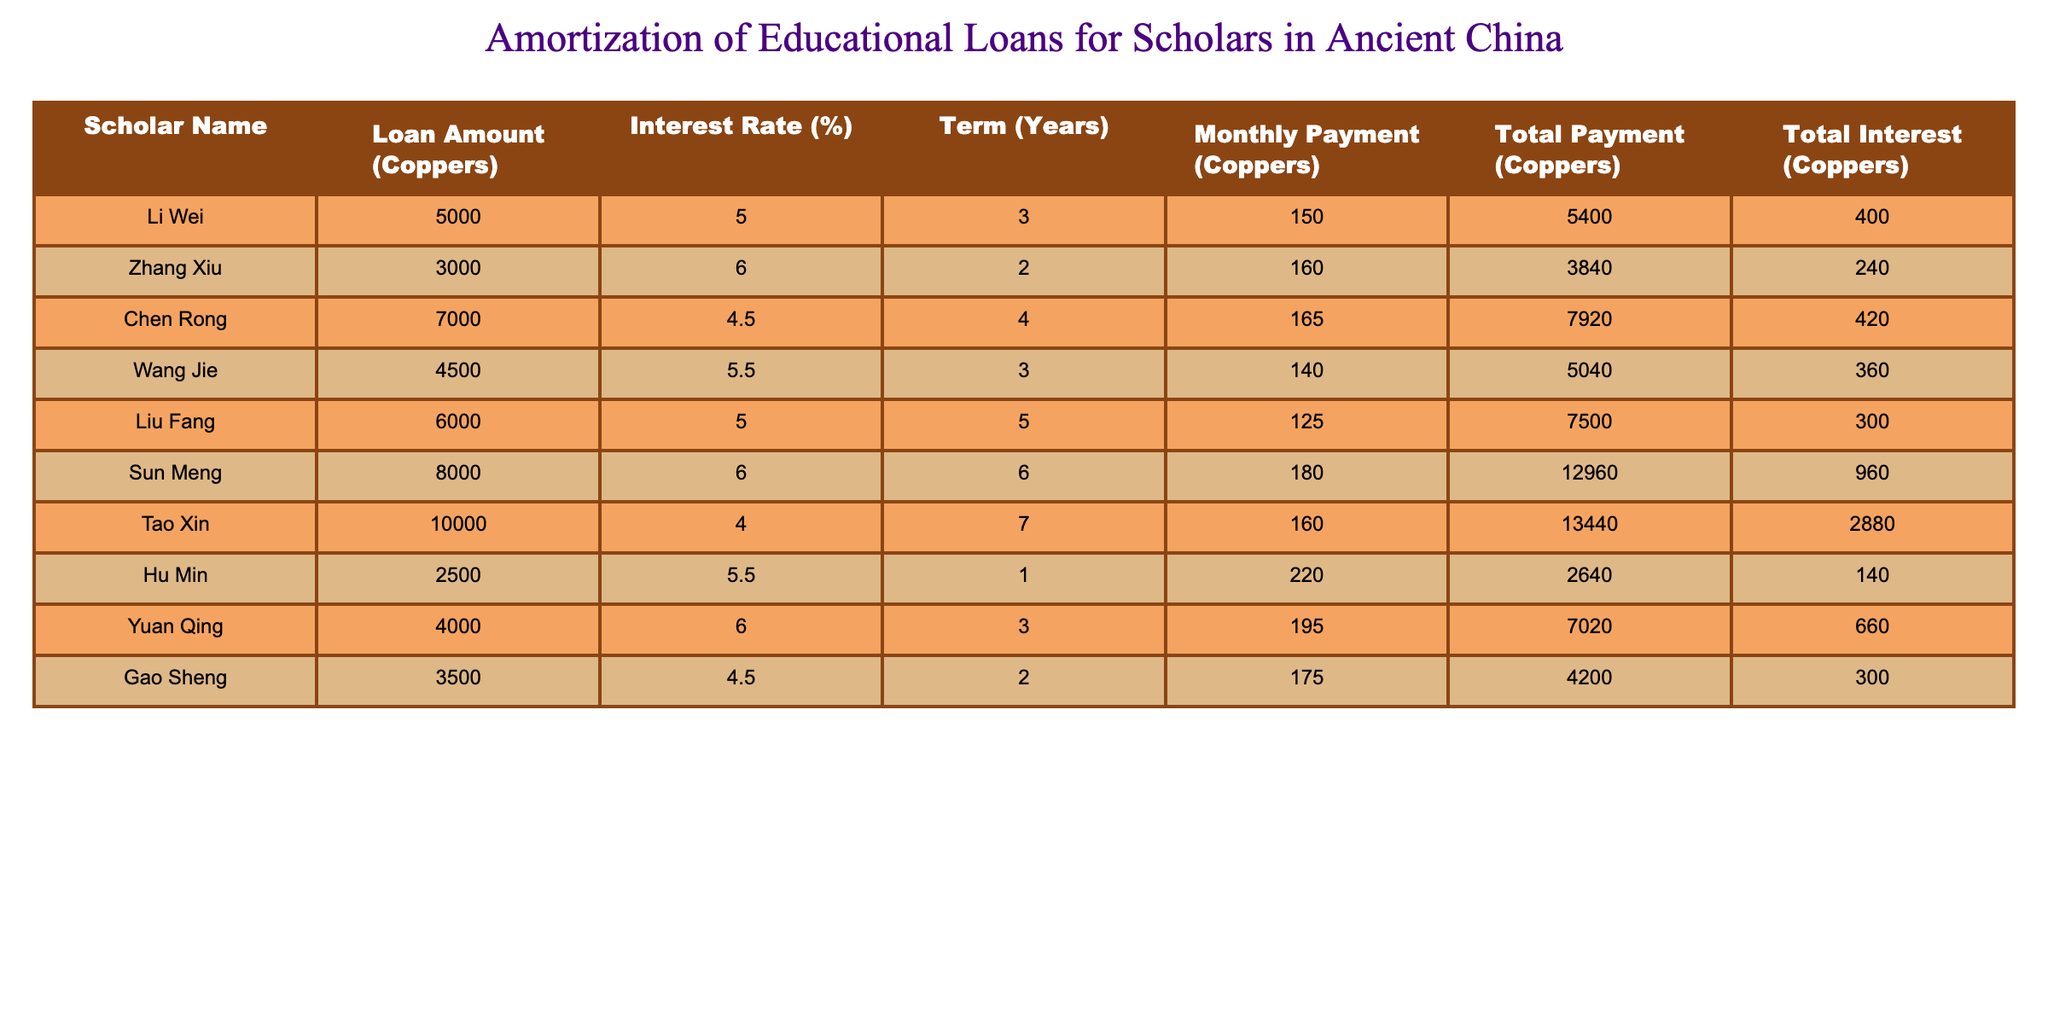What is the loan amount for Li Wei? The table lists the loan amounts for each scholar, and for Li Wei, the value is specified in the corresponding row under the "Loan Amount (Coppers)" column, which shows 5000.
Answer: 5000 What is the total interest paid by Sun Meng? Looking at the row for Sun Meng, the "Total Interest (Coppers)" column indicates that Sun Meng paid a total interest of 960.
Answer: 960 Which scholar has the lowest monthly payment? By examining the "Monthly Payment (Coppers)" column, we see that Hu Min has the lowest payment listed as 220. This is the only value above other payments in the column.
Answer: Hu Min What is the average total payment across all scholars? First, sum all the values in the "Total Payment (Coppers)" column: 5400 + 3840 + 7920 + 5040 + 7500 + 12960 + 13440 + 2640 + 7020 + 4200 =  62240. Then, divide by the number of scholars (10): 62240 / 10 = 6224.
Answer: 6224 Does Tao Xin have a higher interest rate than Chen Rong? Reviewing the "Interest Rate (%)" column, Tao Xin has an interest rate of 4% while Chen Rong has 4.5%. Therefore, Tao Xin does not have a higher interest rate.
Answer: No Which scholar has the highest total interest and what is that amount? Check the "Total Interest (Coppers)" column for the maximum value. The highest interest payment is 2880, corresponding to Tao Xin, indicating he has the highest total interest.
Answer: Tao Xin, 2880 What is the difference between the loan amount of Zhang Xiu and the loan amount of Gan Sheng? The loan amount for Zhang Xiu is 3000 and Gao Sheng’s is 3500. The difference can be found by subtracting Zhang Xiu’s loan amount from Gao Sheng’s: 3500 - 3000 = 500.
Answer: 500 How many scholars have an interest rate of 5% or higher? To determine this, look through the "Interest Rate (%)" column and count those at or above 5%. The scholars with rates of 5% or higher are: Li Wei, Zhang Xiu, Wang Jie, Liu Fang, Sun Meng, and Yuan Qing. That's 6 scholars.
Answer: 6 What is the total payment made by Liu Fang, and how does it compare to the average payment? Liu Fang's total payment is stated as 7500. From previously calculated average payment of 6224, Liu Fang's payment is above average since 7500 > 6224.
Answer: Above average 